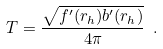<formula> <loc_0><loc_0><loc_500><loc_500>T = \frac { \sqrt { f ^ { \prime } ( r _ { h } ) b ^ { \prime } ( r _ { h } ) } } { 4 \pi } \ .</formula> 